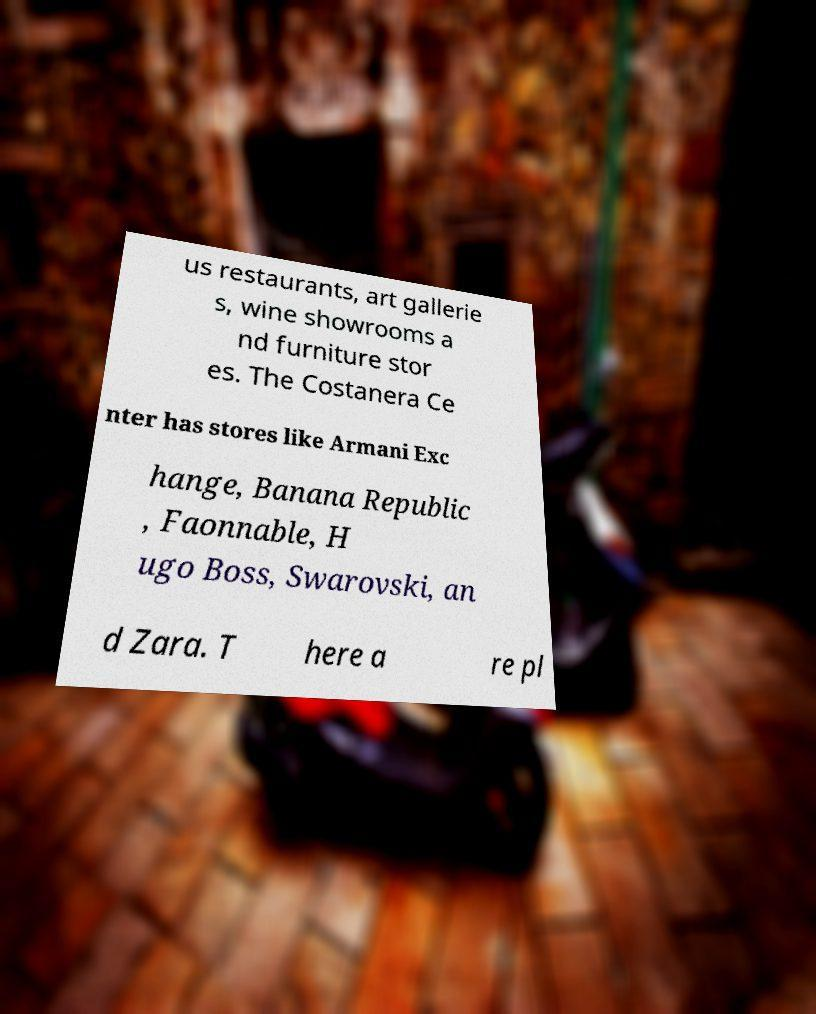Can you read and provide the text displayed in the image?This photo seems to have some interesting text. Can you extract and type it out for me? us restaurants, art gallerie s, wine showrooms a nd furniture stor es. The Costanera Ce nter has stores like Armani Exc hange, Banana Republic , Faonnable, H ugo Boss, Swarovski, an d Zara. T here a re pl 